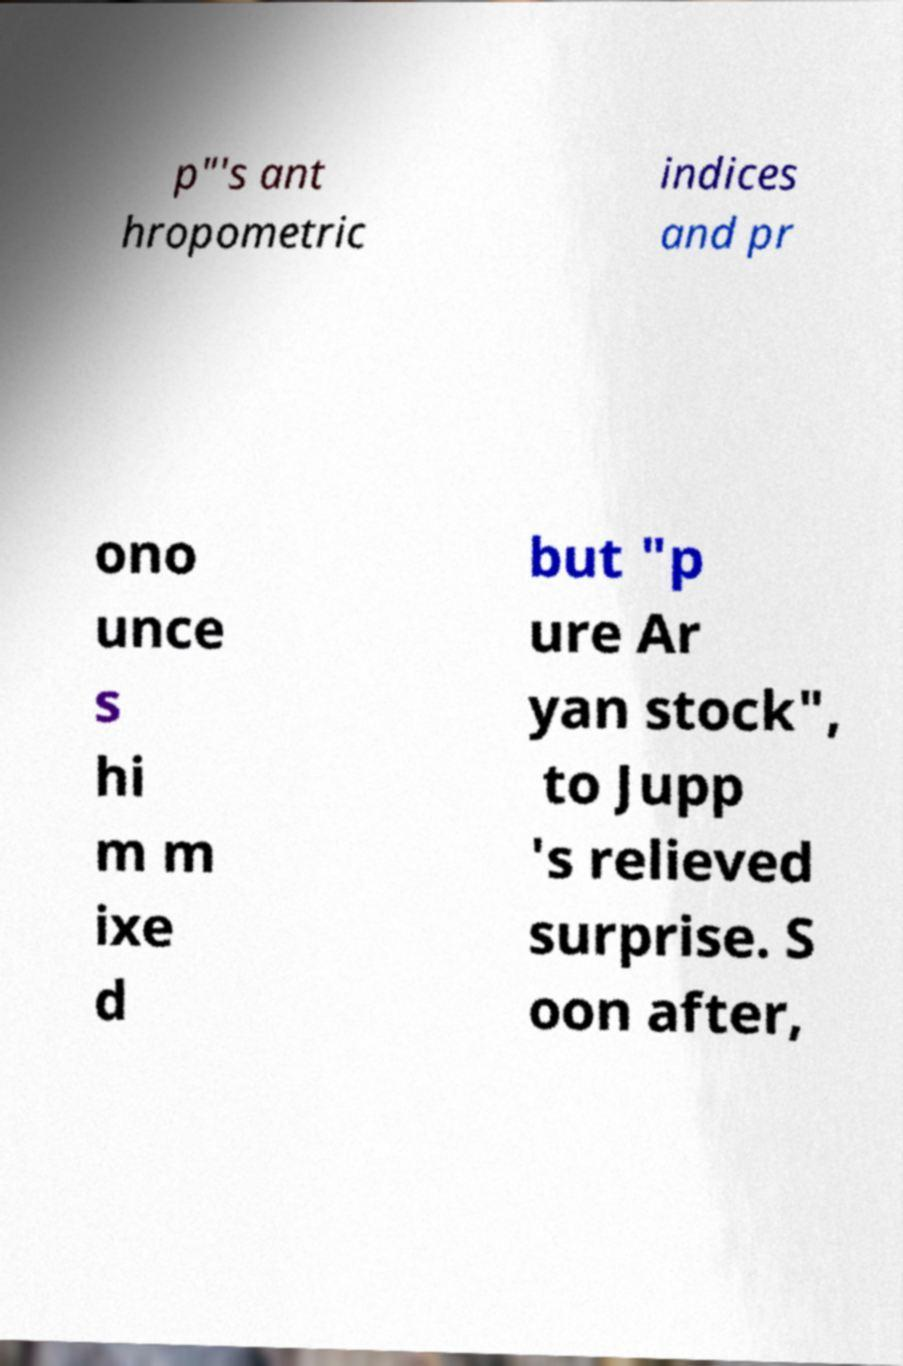Please identify and transcribe the text found in this image. p"'s ant hropometric indices and pr ono unce s hi m m ixe d but "p ure Ar yan stock", to Jupp 's relieved surprise. S oon after, 